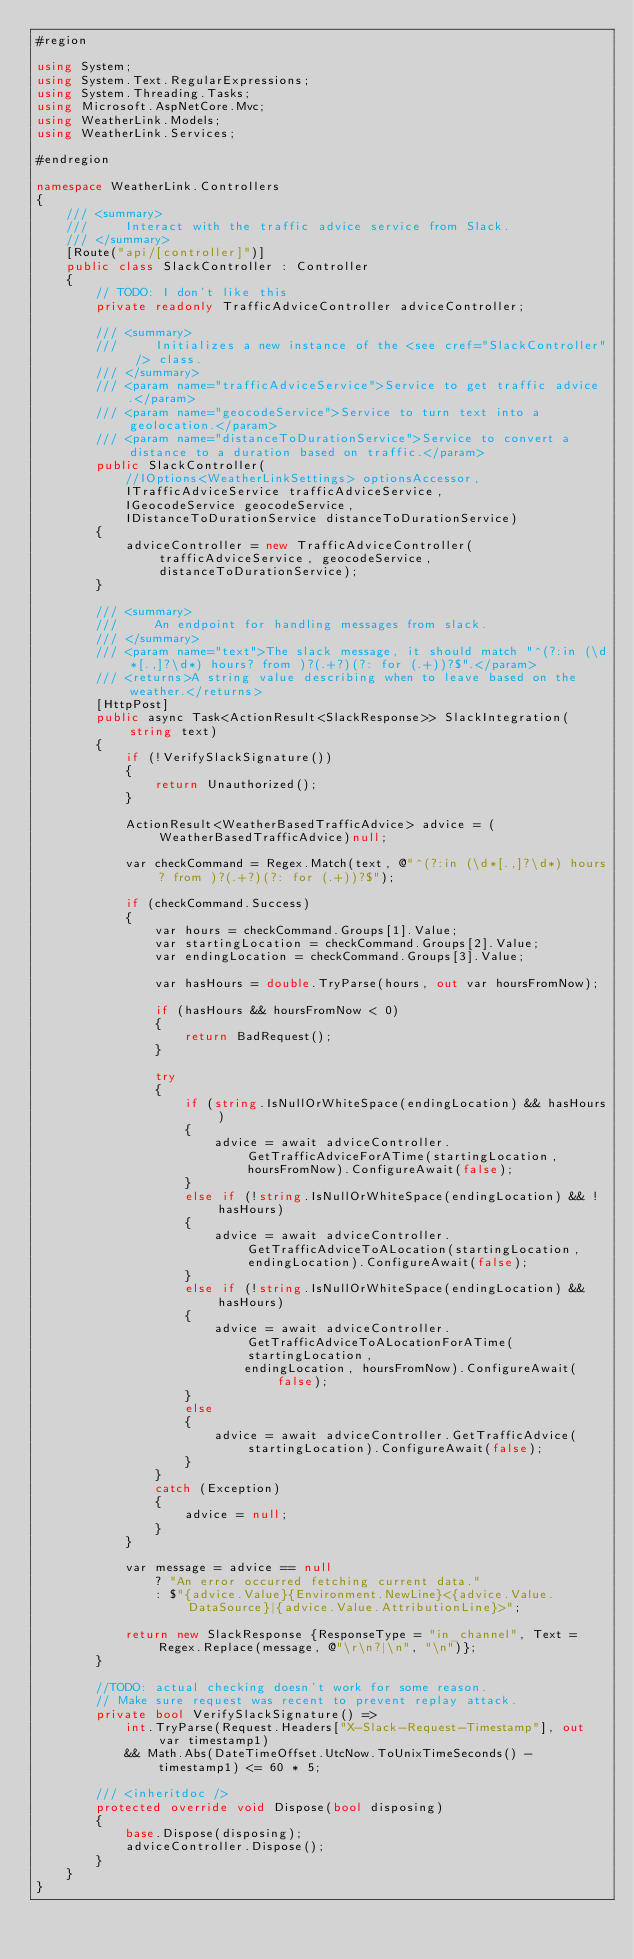Convert code to text. <code><loc_0><loc_0><loc_500><loc_500><_C#_>#region

using System;
using System.Text.RegularExpressions;
using System.Threading.Tasks;
using Microsoft.AspNetCore.Mvc;
using WeatherLink.Models;
using WeatherLink.Services;

#endregion

namespace WeatherLink.Controllers
{
    /// <summary>
    ///     Interact with the traffic advice service from Slack.
    /// </summary>
    [Route("api/[controller]")]
    public class SlackController : Controller
    {
        // TODO: I don't like this
        private readonly TrafficAdviceController adviceController;

        /// <summary>
        ///     Initializes a new instance of the <see cref="SlackController" /> class.
        /// </summary>
        /// <param name="trafficAdviceService">Service to get traffic advice.</param>
        /// <param name="geocodeService">Service to turn text into a geolocation.</param>
        /// <param name="distanceToDurationService">Service to convert a distance to a duration based on traffic.</param>
        public SlackController(
            //IOptions<WeatherLinkSettings> optionsAccessor,
            ITrafficAdviceService trafficAdviceService,
            IGeocodeService geocodeService,
            IDistanceToDurationService distanceToDurationService)
        {
            adviceController = new TrafficAdviceController(trafficAdviceService, geocodeService, distanceToDurationService);
        }

        /// <summary>
        ///     An endpoint for handling messages from slack.
        /// </summary>
        /// <param name="text">The slack message, it should match "^(?:in (\d*[.,]?\d*) hours? from )?(.+?)(?: for (.+))?$".</param>
        /// <returns>A string value describing when to leave based on the weather.</returns>
        [HttpPost]
        public async Task<ActionResult<SlackResponse>> SlackIntegration(string text)
        {
            if (!VerifySlackSignature())
            {
                return Unauthorized();
            }

            ActionResult<WeatherBasedTrafficAdvice> advice = (WeatherBasedTrafficAdvice)null;

            var checkCommand = Regex.Match(text, @"^(?:in (\d*[.,]?\d*) hours? from )?(.+?)(?: for (.+))?$");

            if (checkCommand.Success)
            {
                var hours = checkCommand.Groups[1].Value;
                var startingLocation = checkCommand.Groups[2].Value;
                var endingLocation = checkCommand.Groups[3].Value;

                var hasHours = double.TryParse(hours, out var hoursFromNow);

                if (hasHours && hoursFromNow < 0)
                {
                    return BadRequest();
                }

                try
                {
                    if (string.IsNullOrWhiteSpace(endingLocation) && hasHours)
                    {
                        advice = await adviceController.GetTrafficAdviceForATime(startingLocation, hoursFromNow).ConfigureAwait(false);
                    }
                    else if (!string.IsNullOrWhiteSpace(endingLocation) && !hasHours)
                    {
                        advice = await adviceController.GetTrafficAdviceToALocation(startingLocation, endingLocation).ConfigureAwait(false);
                    }
                    else if (!string.IsNullOrWhiteSpace(endingLocation) && hasHours)
                    {
                        advice = await adviceController.GetTrafficAdviceToALocationForATime(startingLocation,
                            endingLocation, hoursFromNow).ConfigureAwait(false);
                    }
                    else
                    {
                        advice = await adviceController.GetTrafficAdvice(startingLocation).ConfigureAwait(false);
                    }
                }
                catch (Exception)
                {
                    advice = null;
                }
            }

            var message = advice == null
                ? "An error occurred fetching current data."
                : $"{advice.Value}{Environment.NewLine}<{advice.Value.DataSource}|{advice.Value.AttributionLine}>";
            
            return new SlackResponse {ResponseType = "in_channel", Text = Regex.Replace(message, @"\r\n?|\n", "\n")};
        }

        //TODO: actual checking doesn't work for some reason.
        // Make sure request was recent to prevent replay attack.
        private bool VerifySlackSignature() =>
            int.TryParse(Request.Headers["X-Slack-Request-Timestamp"], out var timestamp1)
            && Math.Abs(DateTimeOffset.UtcNow.ToUnixTimeSeconds() - timestamp1) <= 60 * 5;

        /// <inheritdoc />
        protected override void Dispose(bool disposing)
        {
            base.Dispose(disposing);
            adviceController.Dispose();
        }
    }
}</code> 